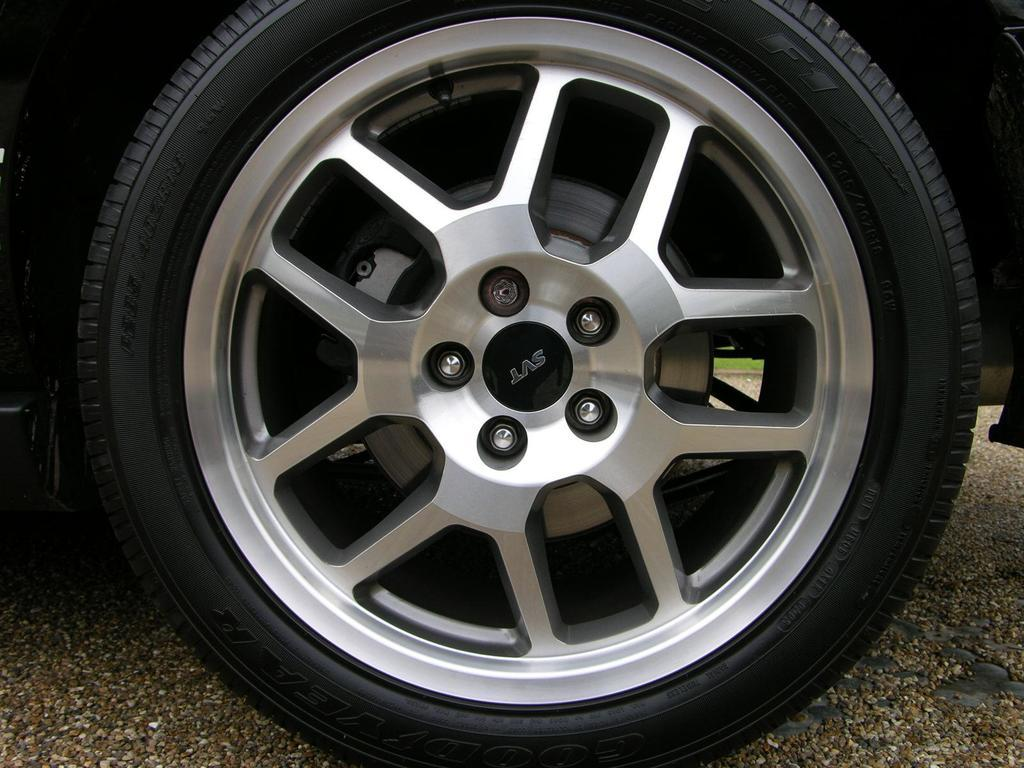What object is located at the front of the image? There is a tyre in the front of the image. What type of terrain is visible in the background of the image? There is grass on the ground in the background of the image. How does the carriage help the home in the image? There is no carriage or home present in the image, so it is not possible to determine how a carriage might help a home. 